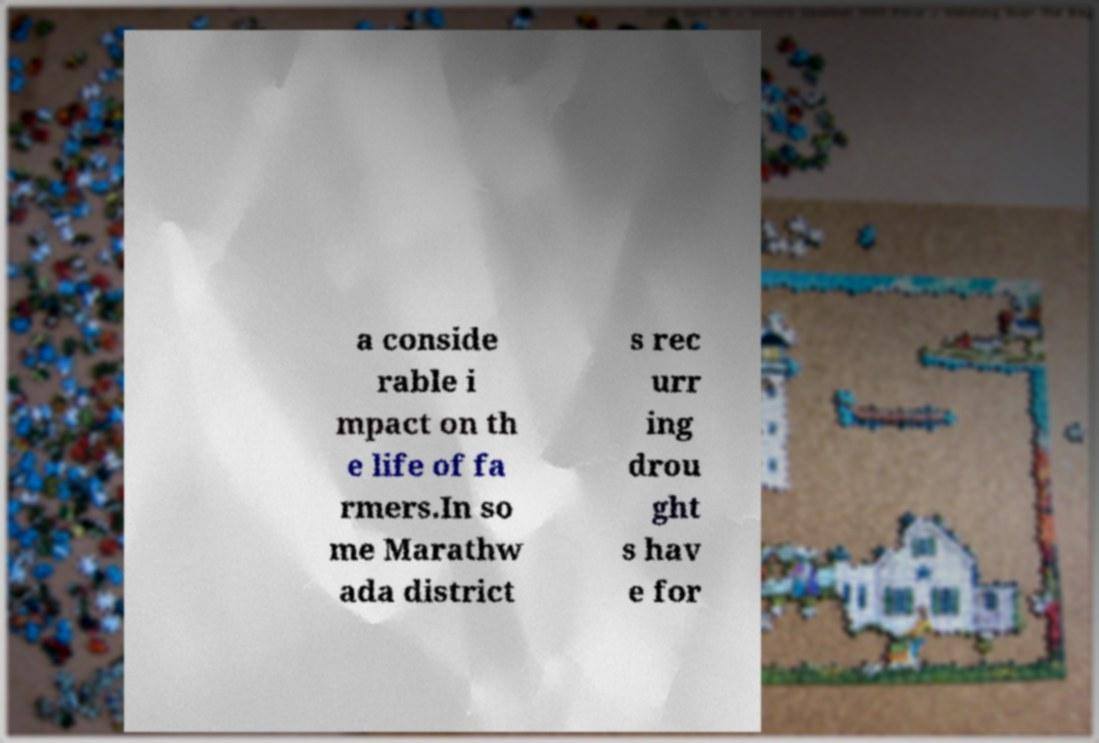Please read and relay the text visible in this image. What does it say? a conside rable i mpact on th e life of fa rmers.In so me Marathw ada district s rec urr ing drou ght s hav e for 